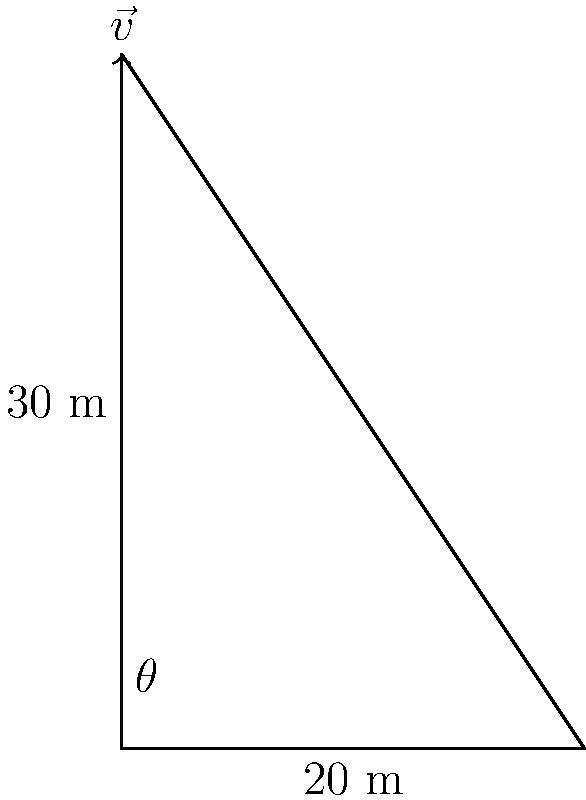The iconic bell tower of the Convent of Jesus and Mary, Shimla, can be represented by a vector $\vec{v}$. If the tower is 30 meters tall and leans 20 meters to the east, what is the magnitude of $\vec{v}$ and its angle $\theta$ with respect to the ground? Let's approach this step-by-step:

1) We can represent the bell tower as a right-angled triangle, where:
   - The height is 30 meters (vertical component)
   - The lean is 20 meters (horizontal component)

2) To find the magnitude of $\vec{v}$, we use the Pythagorean theorem:
   $|\vec{v}| = \sqrt{30^2 + 20^2} = \sqrt{900 + 400} = \sqrt{1300} \approx 36.06$ meters

3) To find the angle $\theta$, we use the arctangent function:
   $\theta = \arctan(\frac{\text{opposite}}{\text{adjacent}}) = \arctan(\frac{30}{20}) = \arctan(1.5)$

4) Using a calculator or trigonometric tables:
   $\arctan(1.5) \approx 56.31°$

Therefore, the magnitude of $\vec{v}$ is approximately 36.06 meters, and the angle $\theta$ is approximately 56.31° from the ground.
Answer: $|\vec{v}| \approx 36.06$ m, $\theta \approx 56.31°$ 